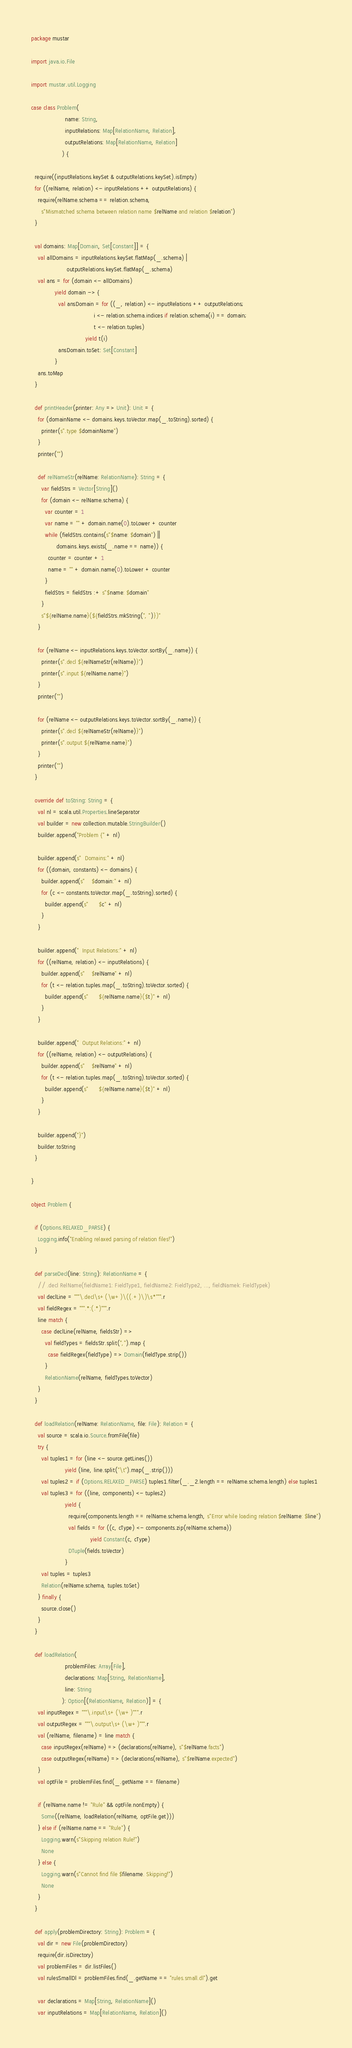Convert code to text. <code><loc_0><loc_0><loc_500><loc_500><_Scala_>package mustar

import java.io.File

import mustar.util.Logging

case class Problem(
                    name: String,
                    inputRelations: Map[RelationName, Relation],
                    outputRelations: Map[RelationName, Relation]
                  ) {

  require((inputRelations.keySet & outputRelations.keySet).isEmpty)
  for ((relName, relation) <- inputRelations ++ outputRelations) {
    require(relName.schema == relation.schema,
      s"Mismatched schema between relation name $relName and relation $relation")
  }

  val domains: Map[Domain, Set[Constant]] = {
    val allDomains = inputRelations.keySet.flatMap(_.schema) |
                     outputRelations.keySet.flatMap(_.schema)
    val ans = for (domain <- allDomains)
              yield domain -> {
                val ansDomain = for ((_, relation) <- inputRelations ++ outputRelations;
                                     i <- relation.schema.indices if relation.schema(i) == domain;
                                     t <- relation.tuples)
                                yield t(i)
                ansDomain.toSet: Set[Constant]
              }
    ans.toMap
  }

  def printHeader(printer: Any => Unit): Unit = {
    for (domainName <- domains.keys.toVector.map(_.toString).sorted) {
      printer(s".type $domainName")
    }
    printer("")

    def relNameStr(relName: RelationName): String = {
      var fieldStrs = Vector[String]()
      for (domain <- relName.schema) {
        var counter = 1
        var name = "" + domain.name(0).toLower + counter
        while (fieldStrs.contains(s"$name: $domain") ||
               domains.keys.exists(_.name == name)) {
          counter = counter + 1
          name = "" + domain.name(0).toLower + counter
        }
        fieldStrs = fieldStrs :+ s"$name: $domain"
      }
      s"${relName.name}(${fieldStrs.mkString(", ")})"
    }

    for (relName <- inputRelations.keys.toVector.sortBy(_.name)) {
      printer(s".decl ${relNameStr(relName)}")
      printer(s".input ${relName.name}")
    }
    printer("")

    for (relName <- outputRelations.keys.toVector.sortBy(_.name)) {
      printer(s".decl ${relNameStr(relName)}")
      printer(s".output ${relName.name}")
    }
    printer("")
  }

  override def toString: String = {
    val nl = scala.util.Properties.lineSeparator
    val builder = new collection.mutable.StringBuilder()
    builder.append("Problem {" + nl)

    builder.append(s"  Domains:" + nl)
    for ((domain, constants) <- domains) {
      builder.append(s"    $domain:" + nl)
      for (c <- constants.toVector.map(_.toString).sorted) {
        builder.append(s"      $c" + nl)
      }
    }

    builder.append("  Input Relations:" + nl)
    for ((relName, relation) <- inputRelations) {
      builder.append(s"    $relName" + nl)
      for (t <- relation.tuples.map(_.toString).toVector.sorted) {
        builder.append(s"      ${relName.name}($t)" + nl)
      }
    }

    builder.append("  Output Relations:" + nl)
    for ((relName, relation) <- outputRelations) {
      builder.append(s"    $relName" + nl)
      for (t <- relation.tuples.map(_.toString).toVector.sorted) {
        builder.append(s"      ${relName.name}($t)" + nl)
      }
    }

    builder.append("}")
    builder.toString
  }

}

object Problem {

  if (Options.RELAXED_PARSE) {
    Logging.info("Enabling relaxed parsing of relation files!")
  }

  def parseDecl(line: String): RelationName = {
    // .decl RelName(fieldName1: FieldType1, fieldName2: FieldType2, ..., fieldNamek: FieldTypek)
    val declLine = """\.decl\s+(\w+)\((.+)\)\s*""".r
    val fieldRegex = """.*:(.*)""".r
    line match {
      case declLine(relName, fieldsStr) =>
        val fieldTypes = fieldsStr.split(",").map {
          case fieldRegex(fieldType) => Domain(fieldType.strip())
        }
        RelationName(relName, fieldTypes.toVector)
    }
  }

  def loadRelation(relName: RelationName, file: File): Relation = {
    val source = scala.io.Source.fromFile(file)
    try {
      val tuples1 = for (line <- source.getLines())
                    yield (line, line.split("\t").map(_.strip()))
      val tuples2 = if (Options.RELAXED_PARSE) tuples1.filter(_._2.length == relName.schema.length) else tuples1
      val tuples3 = for ((line, components) <- tuples2)
                    yield {
                      require(components.length == relName.schema.length, s"Error while loading relation $relName: $line")
                      val fields = for ((c, cType) <- components.zip(relName.schema))
                                   yield Constant(c, cType)
                      DTuple(fields.toVector)
                    }
      val tuples = tuples3
      Relation(relName.schema, tuples.toSet)
    } finally {
      source.close()
    }
  }

  def loadRelation(
                    problemFiles: Array[File],
                    declarations: Map[String, RelationName],
                    line: String
                  ): Option[(RelationName, Relation)] = {
    val inputRegex = """\.input\s+(\w+)""".r
    val outputRegex = """\.output\s+(\w+)""".r
    val (relName, filename) = line match {
      case inputRegex(relName) => (declarations(relName), s"$relName.facts")
      case outputRegex(relName) => (declarations(relName), s"$relName.expected")
    }
    val optFile = problemFiles.find(_.getName == filename)

    if (relName.name != "Rule" && optFile.nonEmpty) {
      Some((relName, loadRelation(relName, optFile.get)))
    } else if (relName.name == "Rule") {
      Logging.warn(s"Skipping relation Rule!")
      None
    } else {
      Logging.warn(s"Cannot find file $filename. Skipping!")
      None
    }
  }

  def apply(problemDirectory: String): Problem = {
    val dir = new File(problemDirectory)
    require(dir.isDirectory)
    val problemFiles = dir.listFiles()
    val rulesSmallDl = problemFiles.find(_.getName == "rules.small.dl").get

    var declarations = Map[String, RelationName]()
    var inputRelations = Map[RelationName, Relation]()</code> 